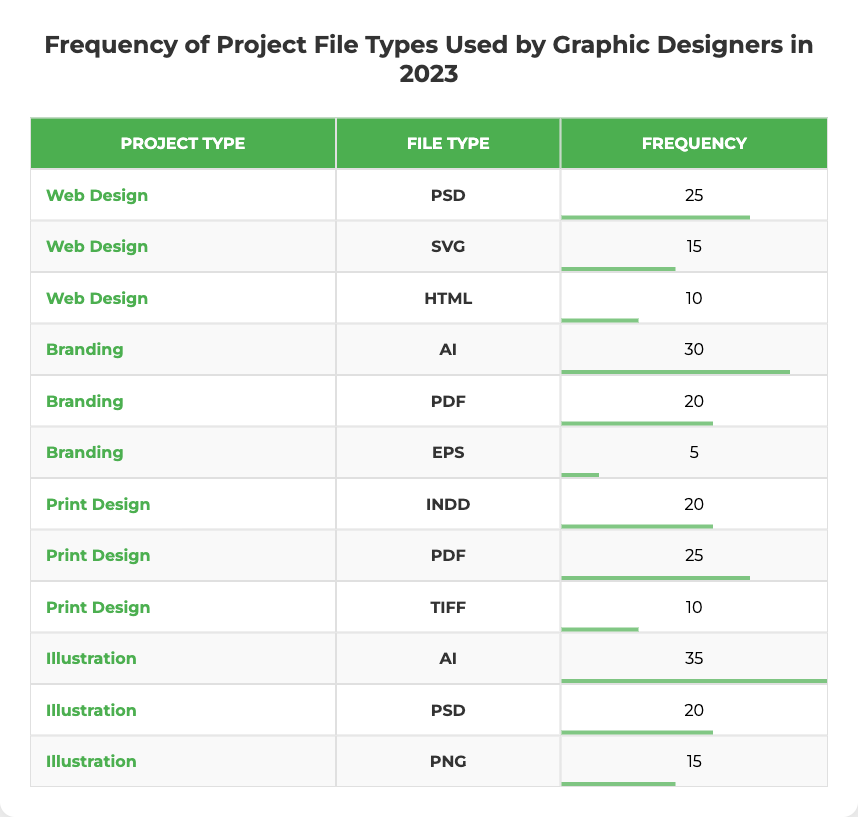What is the frequency of PSD file types used in Web Design projects? According to the table, for Web Design projects, the frequency of PSD file types used is listed as 25.
Answer: 25 Which Project Type has the lowest frequency file type entry and what is that frequency? The lowest frequency in the table is for the EPS file type under the Branding project type, which has a frequency of 5.
Answer: 5 What is the total frequency of file types used in Illustration projects? By summing the frequencies for the Illustration project types, we have AI (35) + PSD (20) + PNG (15) = 70. Therefore, the total frequency is 70.
Answer: 70 Is the frequency of AI file types higher in the Illustration or Branding project types? The frequency for the AI file type in Illustration is 35, while in Branding it is 30. Therefore, the frequency is higher in the Illustration project type.
Answer: Yes How many more times is the frequency of PDF file types used in Print Design than in Branding? In Print Design, the frequency for PDF file types is 25. In Branding, it is 20. Thus, the difference is 25 - 20 = 5. The PDF file types are used 5 more times in Print Design.
Answer: 5 What is the average frequency of all the file types used in Branding projects? For Branding projects, the frequencies are AI (30), PDF (20), and EPS (5). To find the average, sum these values: 30 + 20 + 5 = 55, and divide by the number of file types (3): 55 / 3 = 18.33.
Answer: 18.33 Which file type has the highest usage in all project types combined? By analyzing the table, AI file types (used in both Branding and Illustration) have the highest frequency combined (30 + 35 = 65), therefore making it the most used file type.
Answer: AI How many different project types feature the PDF file type? The table shows the PDF file type used in two project types: Branding and Print Design. Therefore, there are 2 different project types featuring the PDF file type.
Answer: 2 What is the difference in frequency between the most used and least used file type across all project types? The most used file type is AI with a frequency of 35, while the least used is EPS with a frequency of 5. Thus, the difference is 35 - 5 = 30.
Answer: 30 